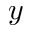Convert formula to latex. <formula><loc_0><loc_0><loc_500><loc_500>y</formula> 